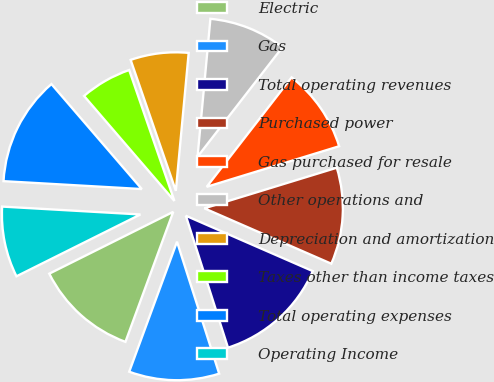Convert chart to OTSL. <chart><loc_0><loc_0><loc_500><loc_500><pie_chart><fcel>Electric<fcel>Gas<fcel>Total operating revenues<fcel>Purchased power<fcel>Gas purchased for resale<fcel>Other operations and<fcel>Depreciation and amortization<fcel>Taxes other than income taxes<fcel>Total operating expenses<fcel>Operating Income<nl><fcel>12.03%<fcel>10.53%<fcel>13.53%<fcel>11.28%<fcel>9.77%<fcel>9.02%<fcel>6.77%<fcel>6.02%<fcel>12.78%<fcel>8.27%<nl></chart> 